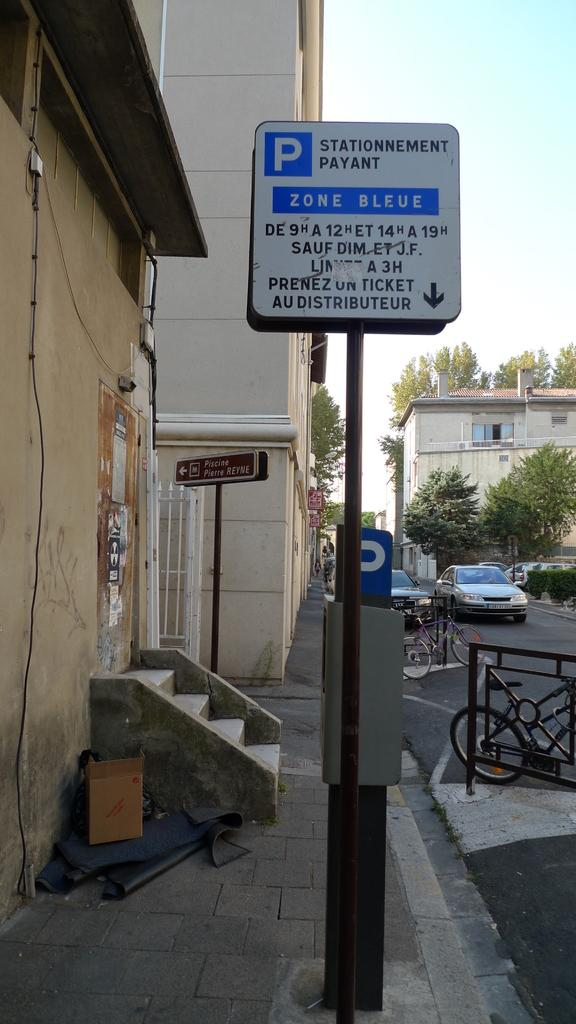What type of structures can be seen in the image? There are buildings in the image. What is hanging or displayed in the image? There is a banner in the image. What mode of transportation is present in the image? There is a bicycle in the image. What type of vehicles can be seen in the image? There are cars in the image. What type of vegetation is present in the image? There are trees in the image. What is visible at the top of the image? The sky is visible at the top of the image. Where is the bulb located in the image? There is no bulb present in the image. What type of picture is hanging on the wall in the image? There is no picture hanging on the wall in the image. 